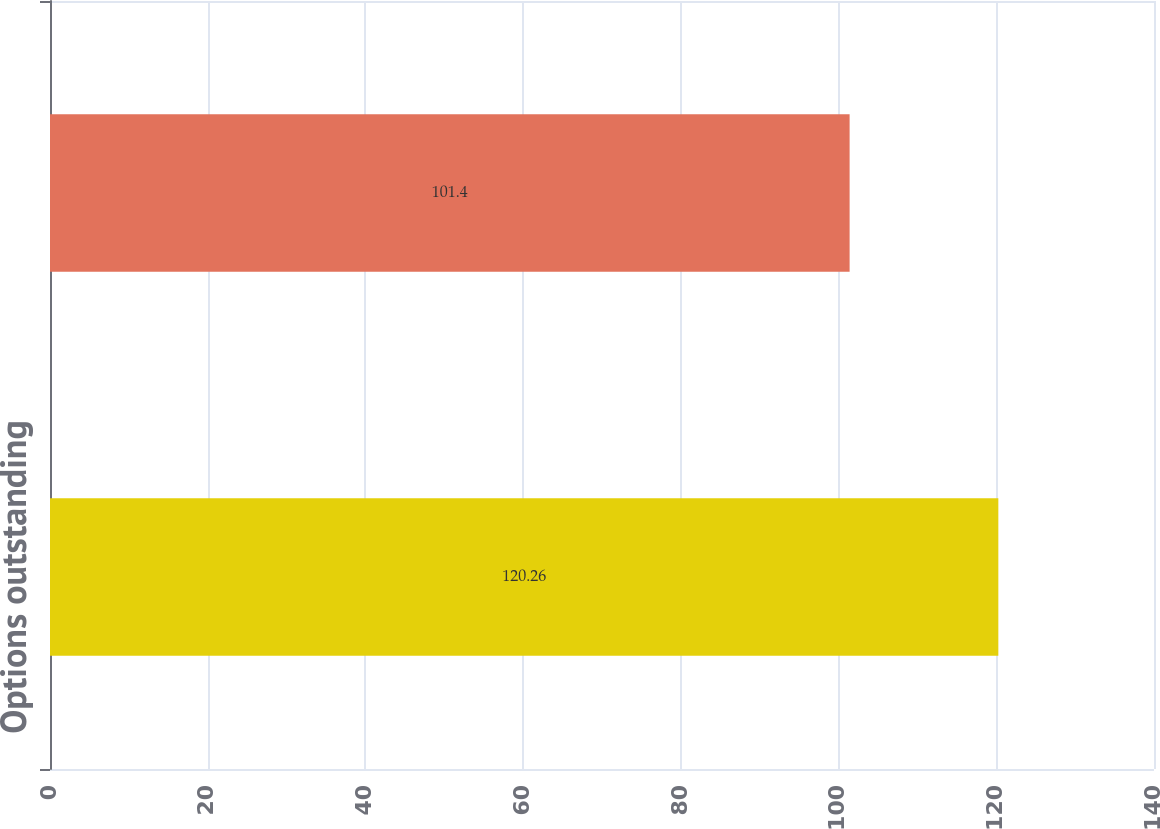Convert chart to OTSL. <chart><loc_0><loc_0><loc_500><loc_500><bar_chart><fcel>Options outstanding<fcel>Options exercisable<nl><fcel>120.26<fcel>101.4<nl></chart> 